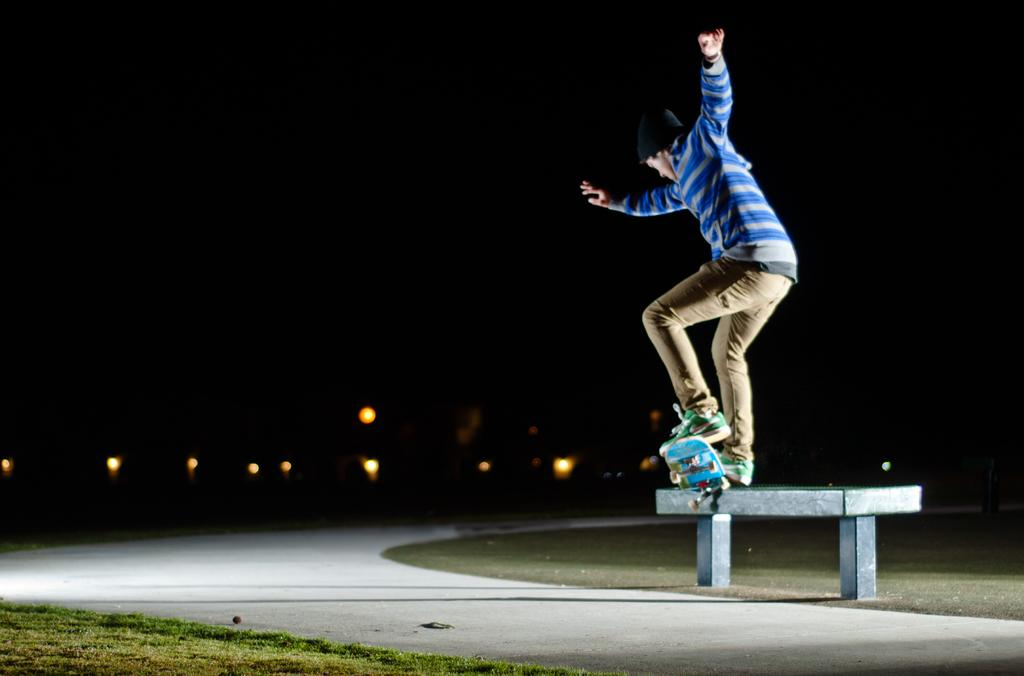What is present in the image? There is a person, a skateboard, a road, grass, a bench, a light, and a dark sky in the image. Can you describe the person's attire in the image? The person is wearing clothes, a cap, and shoes in the image. What object is the person using in the image? The person is using a skateboard in the image. What type of surface can be seen in the image? There is a road and grass in the image. What type of seating is present in the image? There is a bench in the image. What type of lighting is present in the image? There is a light in the image. How would you describe the sky in the image? The sky is dark in the image. What type of produce is being sold on the bench in the image? There is no produce being sold in the image; the bench is a seating area. How much money is the person holding in the image? There is no money visible in the image. 